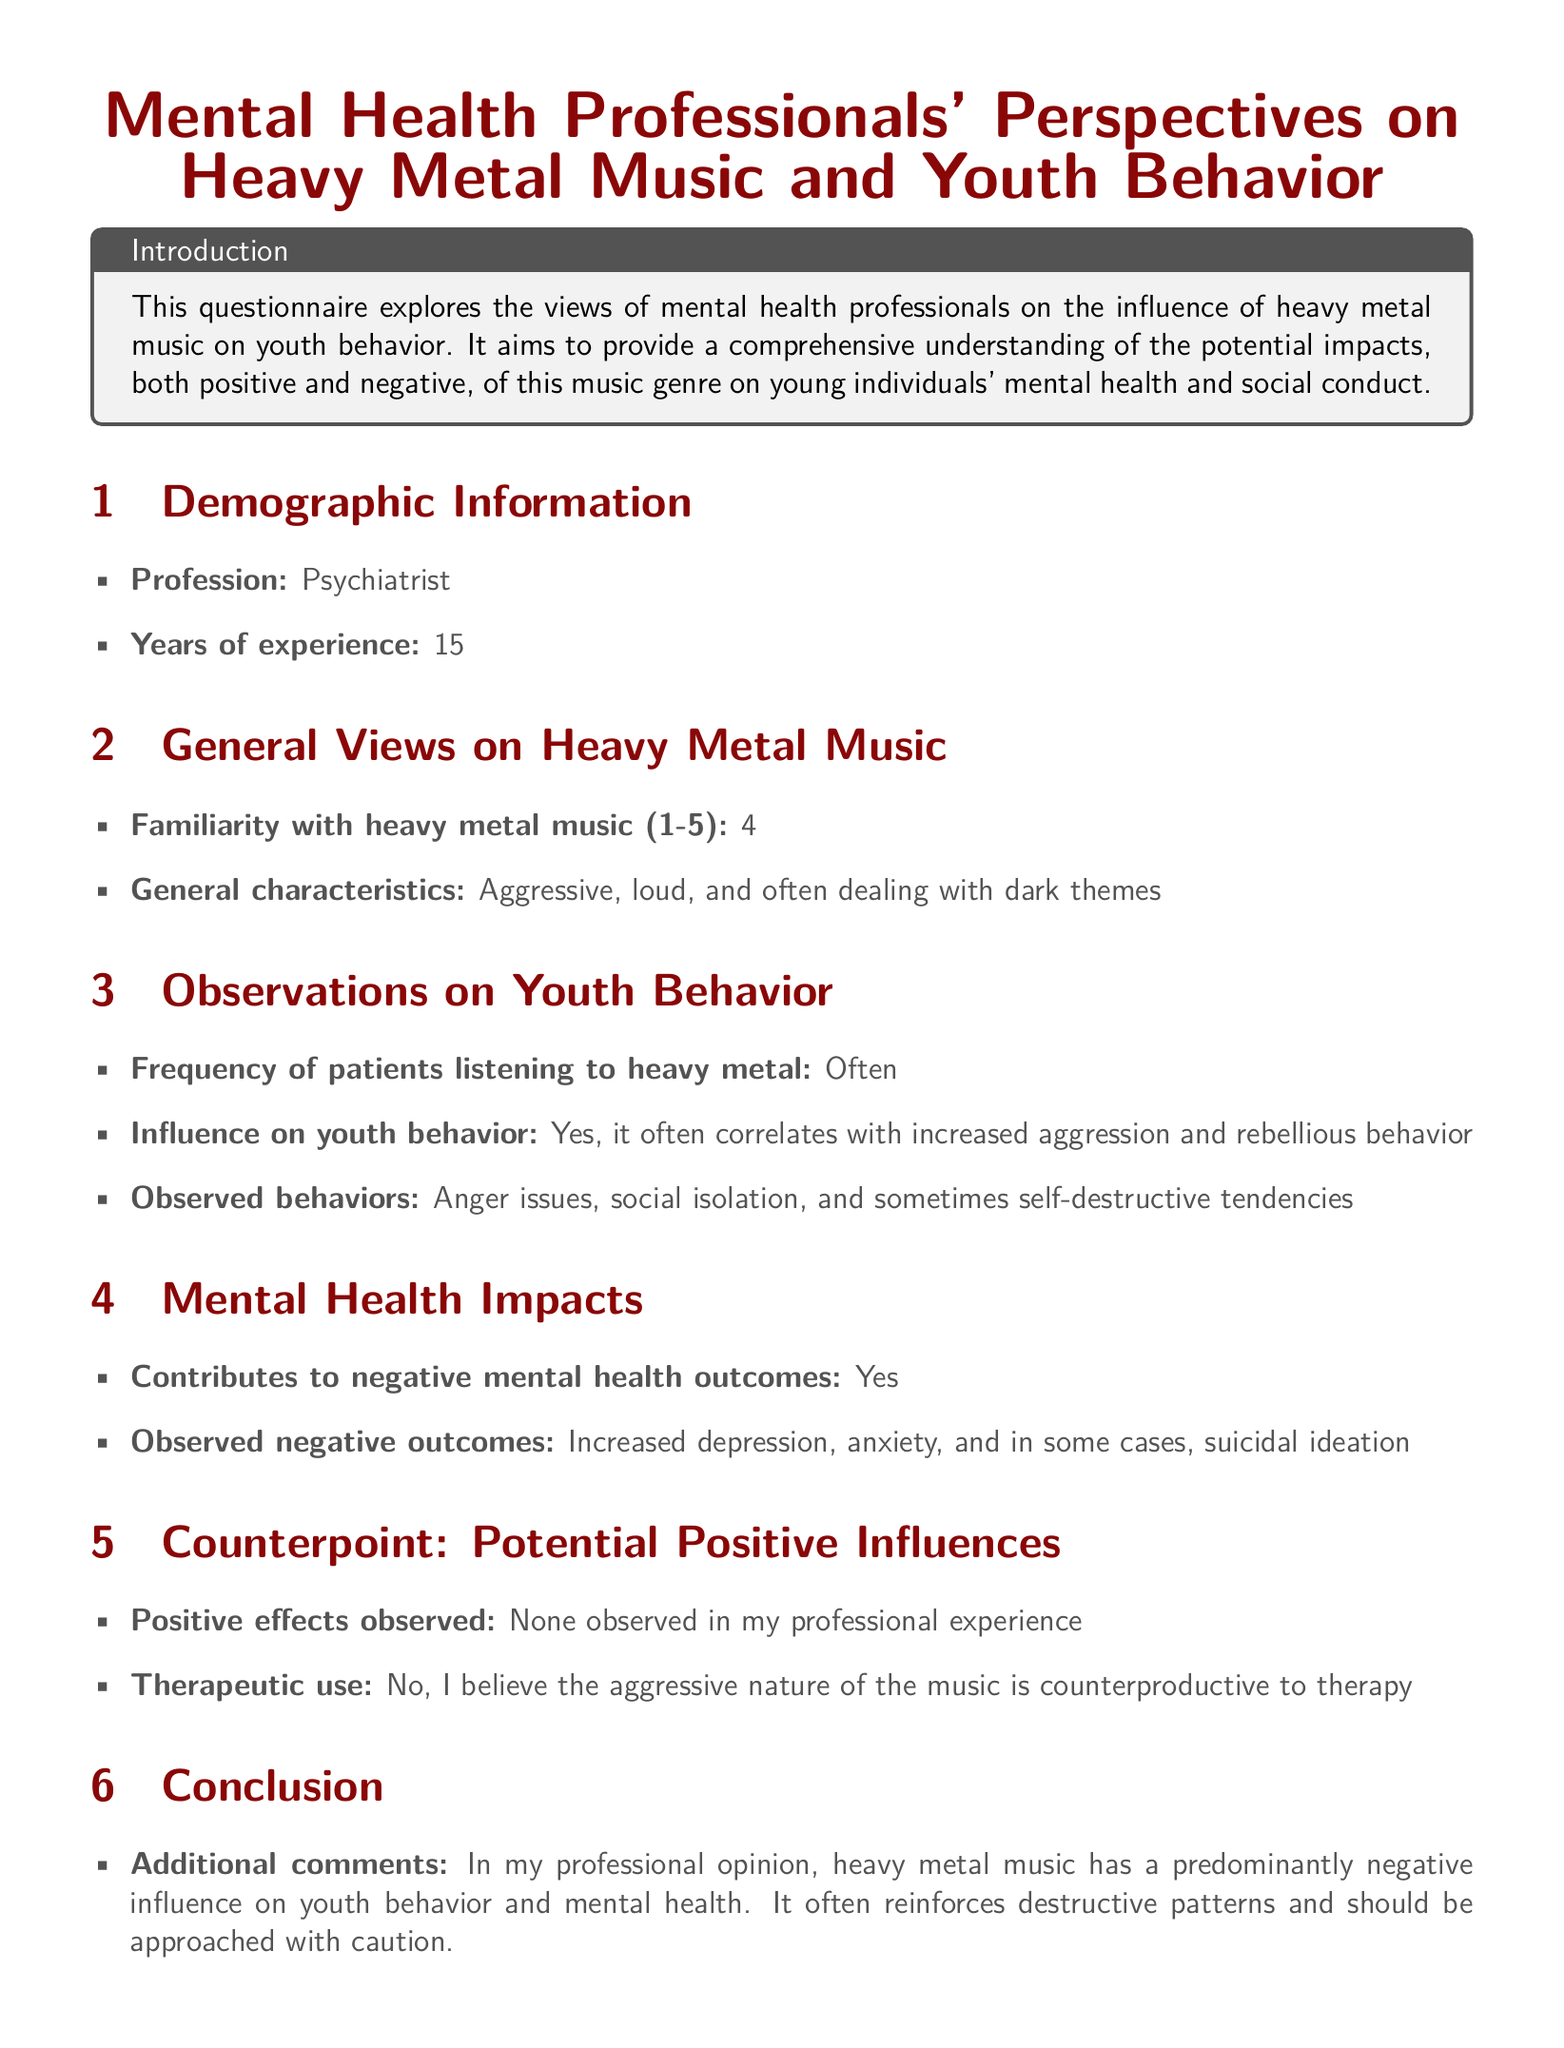what is the profession of the respondent? The document specifies the profession of the respondent as "Psychiatrist."
Answer: Psychiatrist how many years of experience does the respondent have? The years of experience mentioned in the document is "15."
Answer: 15 on a scale from 1 to 5, how familiar is the respondent with heavy metal music? The respondent's familiarity with heavy metal music is rated as "4."
Answer: 4 what general characteristics does the respondent associate with heavy metal music? According to the respondent, heavy metal music is characterized as "Aggressive, loud, and often dealing with dark themes."
Answer: Aggressive, loud, and often dealing with dark themes what negative mental health outcomes are observed by the respondent in youth? The respondent observed "Increased depression, anxiety, and in some cases, suicidal ideation" as negative outcomes.
Answer: Increased depression, anxiety, and in some cases, suicidal ideation did the respondent observe any positive effects of heavy metal music on youth? The respondent stated that there were "None observed in my professional experience."
Answer: None observed in my professional experience what additional comments does the respondent make about heavy metal music's influence? The respondent comments that heavy metal music has a "predominantly negative influence on youth behavior and mental health."
Answer: predominantly negative influence on youth behavior and mental health what does the respondent believe about the therapeutic use of heavy metal music? The respondent believes that the aggressive nature of the music is "counterproductive to therapy."
Answer: counterproductive to therapy 